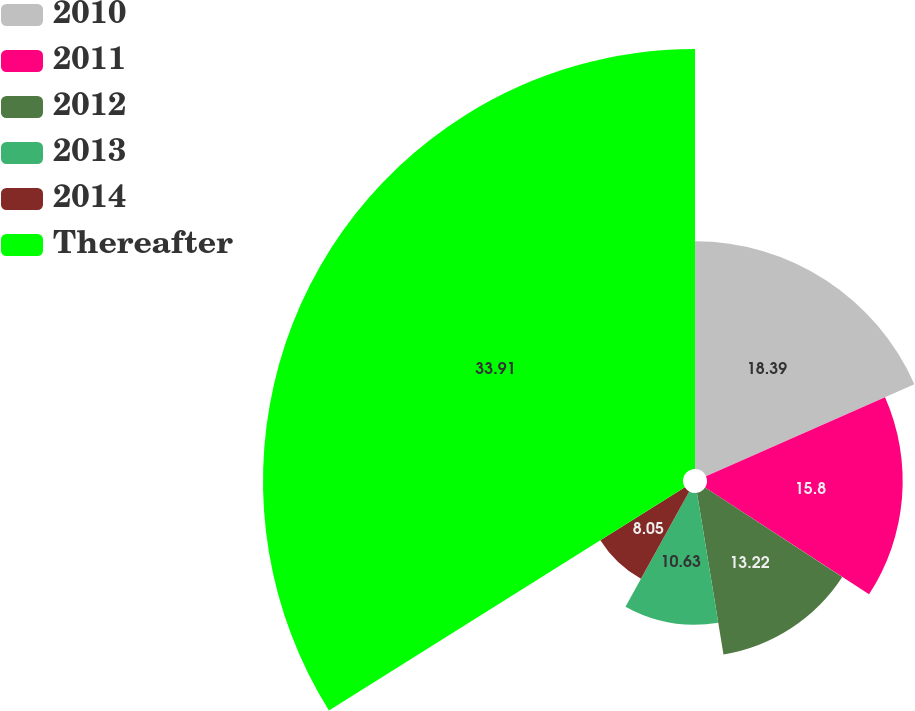<chart> <loc_0><loc_0><loc_500><loc_500><pie_chart><fcel>2010<fcel>2011<fcel>2012<fcel>2013<fcel>2014<fcel>Thereafter<nl><fcel>18.39%<fcel>15.8%<fcel>13.22%<fcel>10.63%<fcel>8.05%<fcel>33.91%<nl></chart> 